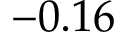Convert formula to latex. <formula><loc_0><loc_0><loc_500><loc_500>- 0 . 1 6</formula> 